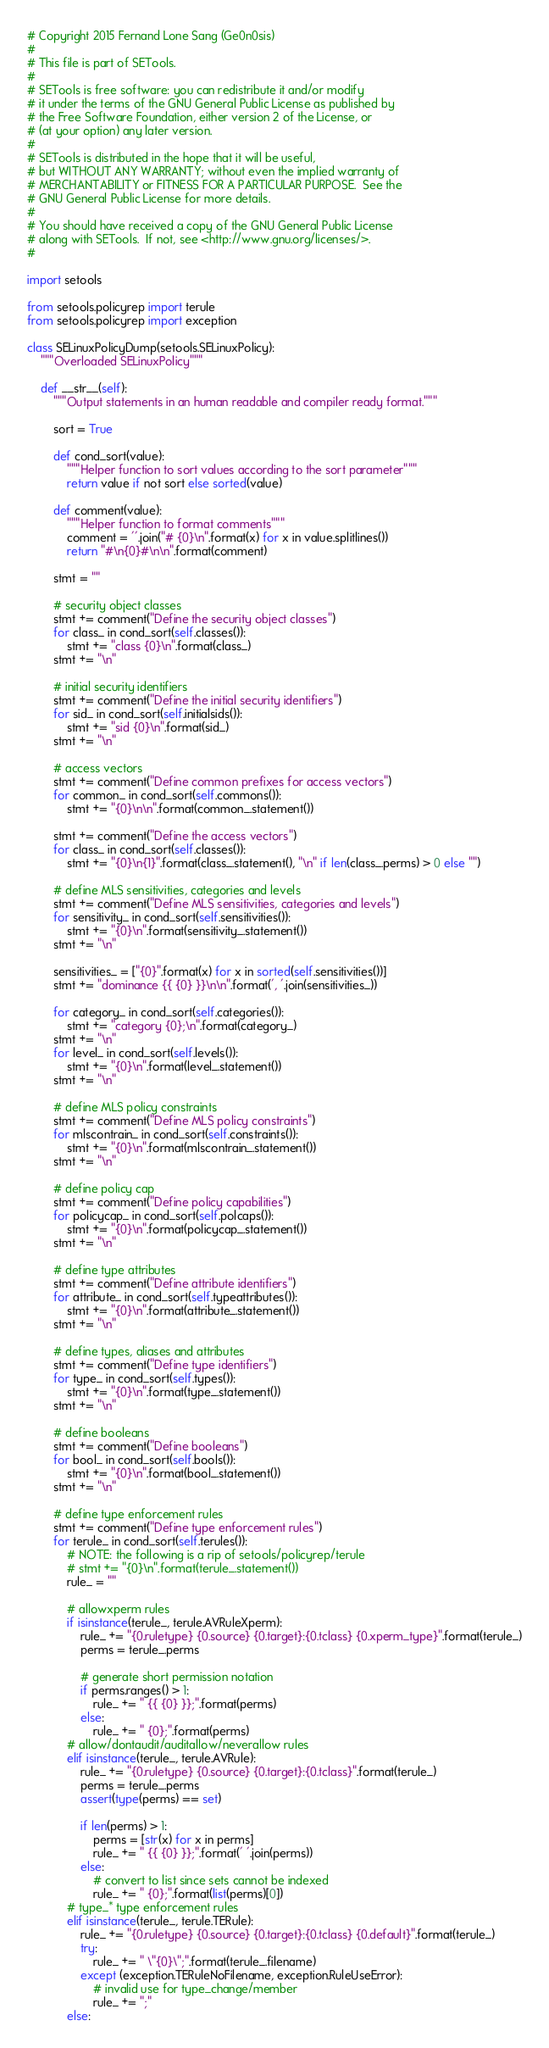Convert code to text. <code><loc_0><loc_0><loc_500><loc_500><_Python_># Copyright 2015 Fernand Lone Sang (Ge0n0sis)
#
# This file is part of SETools.
#
# SETools is free software: you can redistribute it and/or modify
# it under the terms of the GNU General Public License as published by
# the Free Software Foundation, either version 2 of the License, or
# (at your option) any later version.
#
# SETools is distributed in the hope that it will be useful,
# but WITHOUT ANY WARRANTY; without even the implied warranty of
# MERCHANTABILITY or FITNESS FOR A PARTICULAR PURPOSE.  See the
# GNU General Public License for more details.
#
# You should have received a copy of the GNU General Public License
# along with SETools.  If not, see <http://www.gnu.org/licenses/>.
#

import setools

from setools.policyrep import terule
from setools.policyrep import exception

class SELinuxPolicyDump(setools.SELinuxPolicy):
    """Overloaded SELinuxPolicy"""

    def __str__(self):
        """Output statements in an human readable and compiler ready format."""

        sort = True

        def cond_sort(value):
            """Helper function to sort values according to the sort parameter"""
            return value if not sort else sorted(value)

        def comment(value):
            """Helper function to format comments"""
            comment = ''.join("# {0}\n".format(x) for x in value.splitlines())
            return "#\n{0}#\n\n".format(comment)

        stmt = ""

        # security object classes
        stmt += comment("Define the security object classes")
        for class_ in cond_sort(self.classes()):
            stmt += "class {0}\n".format(class_)
        stmt += "\n"

        # initial security identifiers
        stmt += comment("Define the initial security identifiers")
        for sid_ in cond_sort(self.initialsids()):
            stmt += "sid {0}\n".format(sid_)
        stmt += "\n"

        # access vectors
        stmt += comment("Define common prefixes for access vectors")
        for common_ in cond_sort(self.commons()):
            stmt += "{0}\n\n".format(common_.statement())

        stmt += comment("Define the access vectors")
        for class_ in cond_sort(self.classes()):
            stmt += "{0}\n{1}".format(class_.statement(), "\n" if len(class_.perms) > 0 else "")

        # define MLS sensitivities, categories and levels
        stmt += comment("Define MLS sensitivities, categories and levels")
        for sensitivity_ in cond_sort(self.sensitivities()):
            stmt += "{0}\n".format(sensitivity_.statement())
        stmt += "\n"

        sensitivities_ = ["{0}".format(x) for x in sorted(self.sensitivities())]
        stmt += "dominance {{ {0} }}\n\n".format(', '.join(sensitivities_))

        for category_ in cond_sort(self.categories()):
            stmt += "category {0};\n".format(category_)
        stmt += "\n"
        for level_ in cond_sort(self.levels()):
            stmt += "{0}\n".format(level_.statement())
        stmt += "\n"

        # define MLS policy constraints
        stmt += comment("Define MLS policy constraints")
        for mlscontrain_ in cond_sort(self.constraints()):
            stmt += "{0}\n".format(mlscontrain_.statement())
        stmt += "\n"

        # define policy cap
        stmt += comment("Define policy capabilities")
        for policycap_ in cond_sort(self.polcaps()):
            stmt += "{0}\n".format(policycap_.statement())
        stmt += "\n"

        # define type attributes
        stmt += comment("Define attribute identifiers")
        for attribute_ in cond_sort(self.typeattributes()):
            stmt += "{0}\n".format(attribute_.statement())
        stmt += "\n"

        # define types, aliases and attributes
        stmt += comment("Define type identifiers")
        for type_ in cond_sort(self.types()):
            stmt += "{0}\n".format(type_.statement())
        stmt += "\n"

        # define booleans
        stmt += comment("Define booleans")
        for bool_ in cond_sort(self.bools()):
            stmt += "{0}\n".format(bool_.statement())
        stmt += "\n"

        # define type enforcement rules
        stmt += comment("Define type enforcement rules")
        for terule_ in cond_sort(self.terules()):
            # NOTE: the following is a rip of setools/policyrep/terule
            # stmt += "{0}\n".format(terule_.statement())
            rule_ = ""

            # allowxperm rules
            if isinstance(terule_, terule.AVRuleXperm):
                rule_ += "{0.ruletype} {0.source} {0.target}:{0.tclass} {0.xperm_type}".format(terule_)
                perms = terule_.perms

                # generate short permission notation
                if perms.ranges() > 1:
                    rule_ += " {{ {0} }};".format(perms)
                else:
                    rule_ += " {0};".format(perms)
            # allow/dontaudit/auditallow/neverallow rules
            elif isinstance(terule_, terule.AVRule):
                rule_ += "{0.ruletype} {0.source} {0.target}:{0.tclass}".format(terule_)
                perms = terule_.perms
                assert(type(perms) == set)

                if len(perms) > 1:
                    perms = [str(x) for x in perms]
                    rule_ += " {{ {0} }};".format(' '.join(perms))
                else:
                    # convert to list since sets cannot be indexed
                    rule_ += " {0};".format(list(perms)[0])
            # type_* type enforcement rules
            elif isinstance(terule_, terule.TERule):
                rule_ += "{0.ruletype} {0.source} {0.target}:{0.tclass} {0.default}".format(terule_)
                try:
                    rule_ += " \"{0}\";".format(terule_.filename)
                except (exception.TERuleNoFilename, exception.RuleUseError):
                    # invalid use for type_change/member
                    rule_ += ";"
            else:</code> 